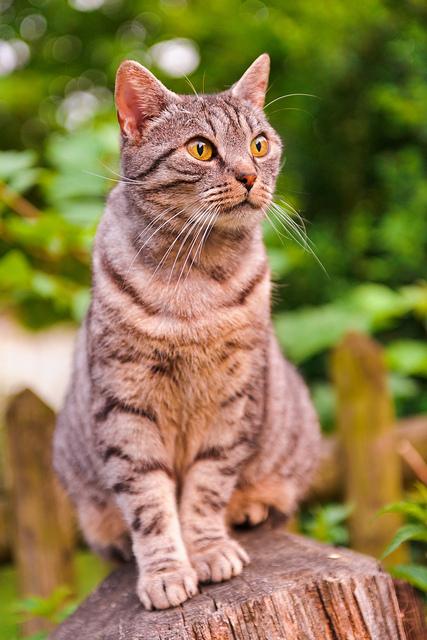Where is the cat sitting?
Answer briefly. Stump. What do you think the cat is looking at?
Short answer required. Bird. Is the cat trying to catch a bird?
Keep it brief. No. 